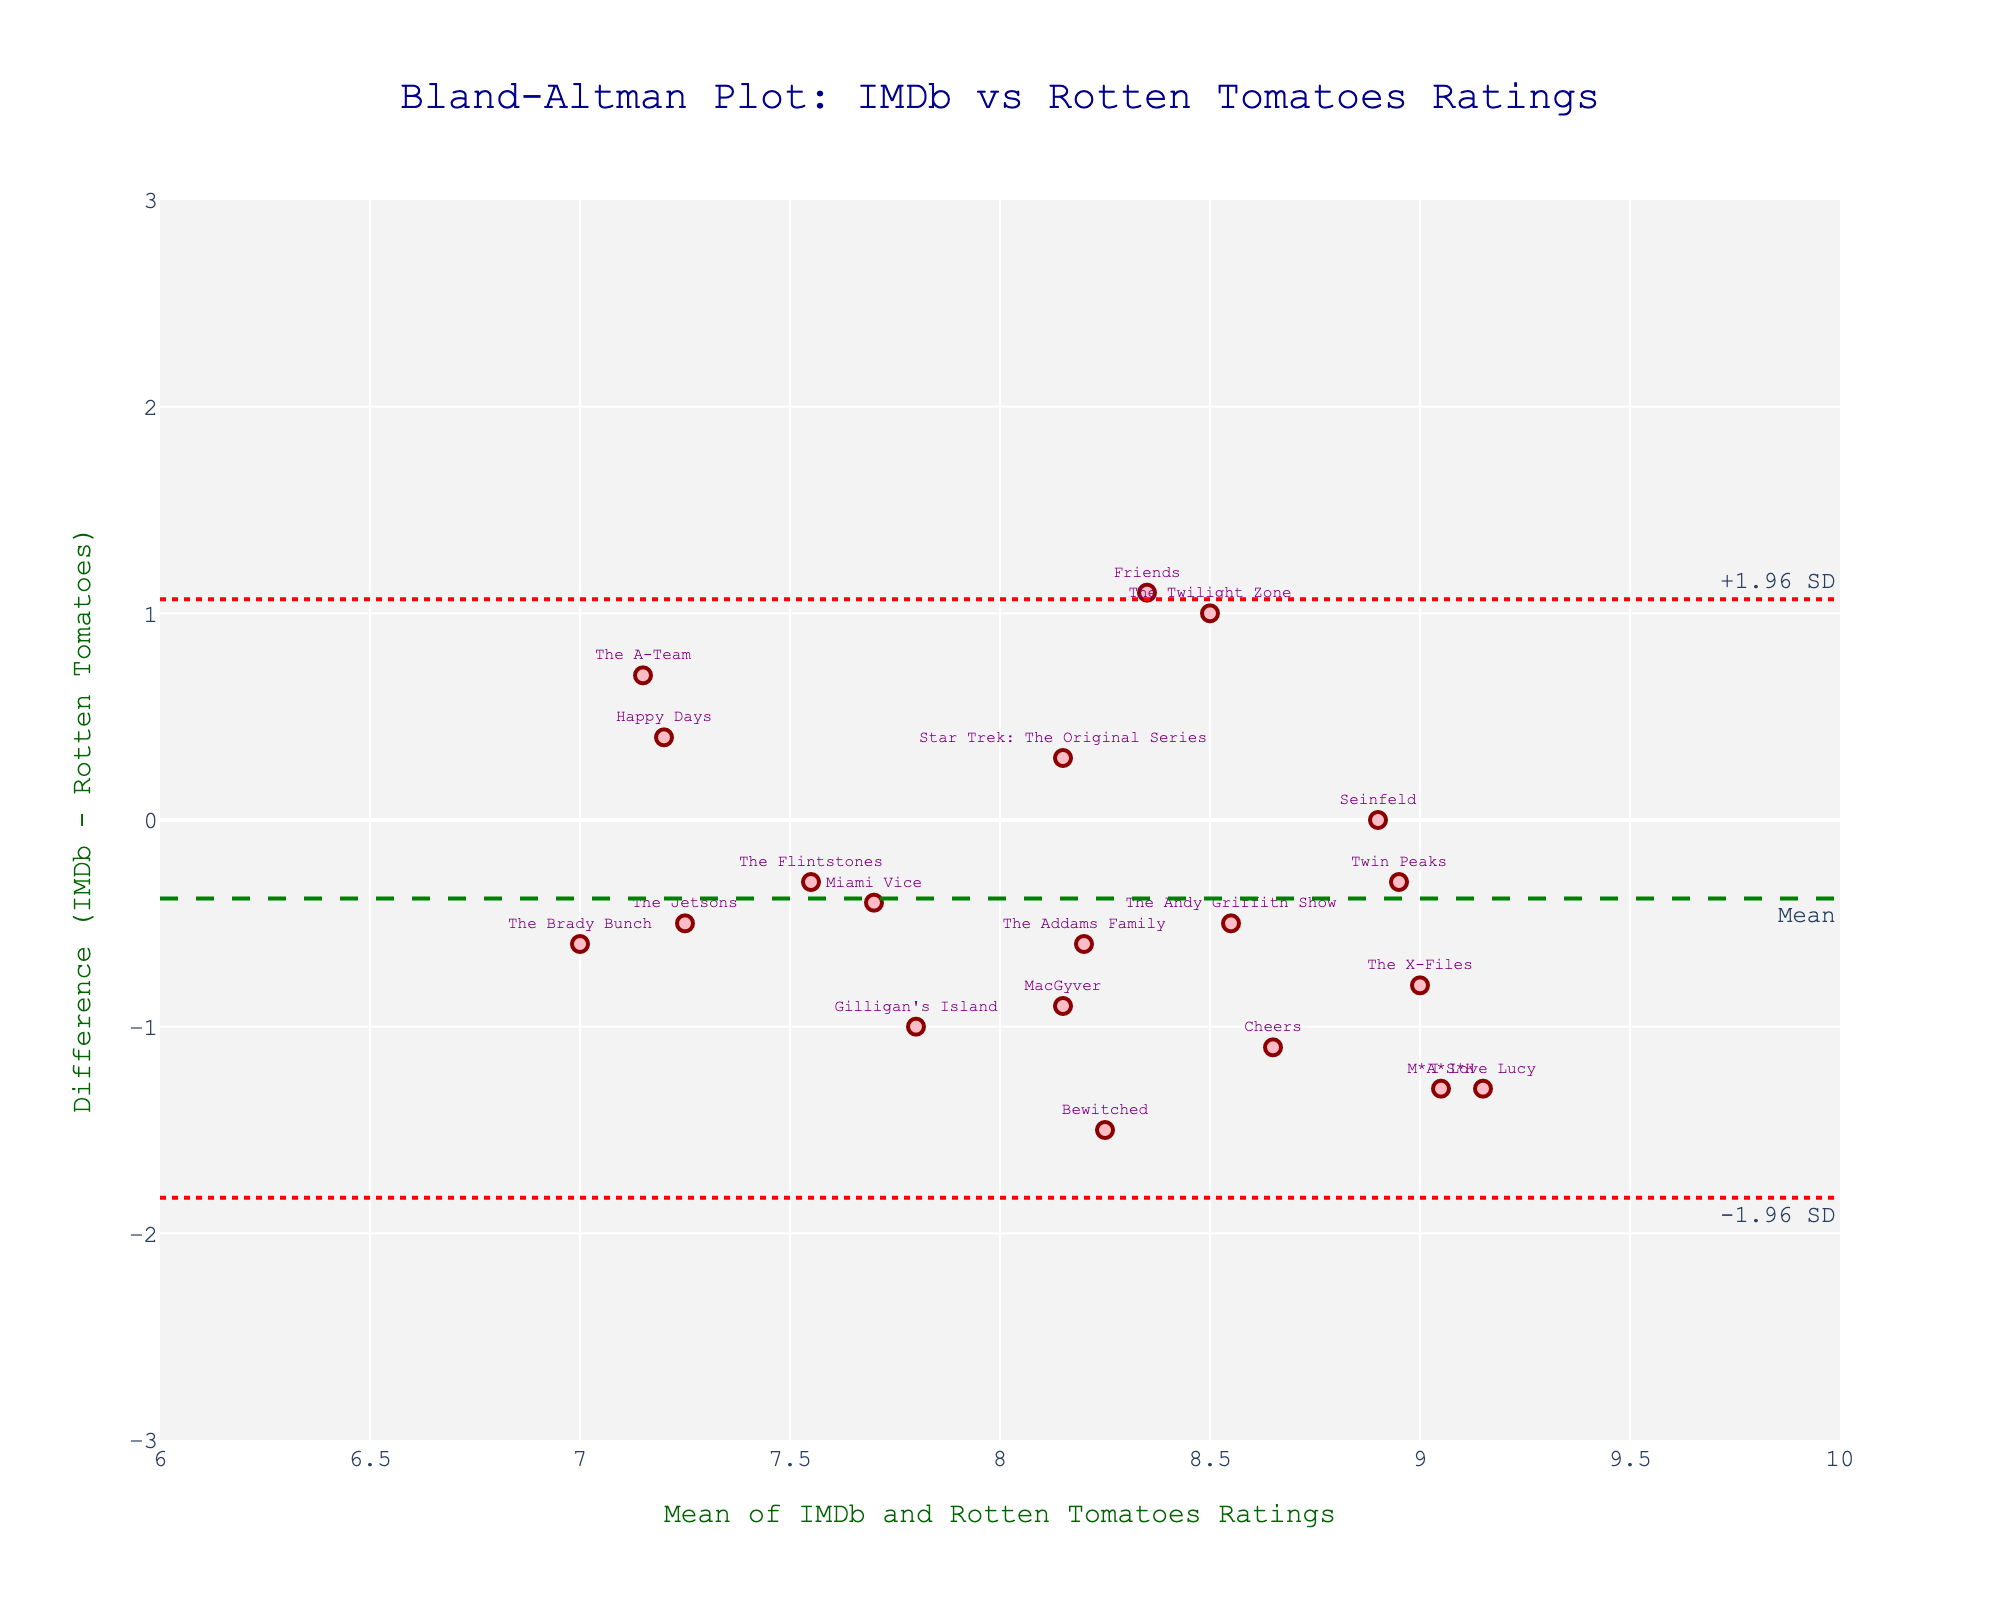What is the title of the figure? The title of the figure is located at the top. It states 'Bland-Altman Plot: IMDb vs Rotten Tomatoes Ratings', indicating the comparison being made between IMDb and Rotten Tomatoes ratings for vintage TV shows.
Answer: Bland-Altman Plot: IMDb vs Rotten Tomatoes Ratings What do the x-axis and y-axis represent? The x-axis represents the 'Mean of IMDb and Rotten Tomatoes Ratings', while the y-axis represents the 'Difference (IMDb - Rotten Tomatoes)'. This is based on the axis titles found on the figure.
Answer: Mean of IMDb and Rotten Tomatoes Ratings, Difference (IMDb - Rotten Tomatoes) How many TV shows are plotted in the figure? Each marker on the plot represents a TV show. By counting the markers, we can see there are 20 markers indicating 20 TV shows.
Answer: 20 Which TV show has the highest mean rating? By finding the marker with the highest x-axis value (mean rating), we can see that 'The Twilight Zone' has the highest mean rating among the plotted shows.
Answer: The Twilight Zone What are the colors of the markers, and what do they signify? The markers are pink with dark red outlines. The colors are used for visual distinction but do not signify any specific grouping or category in the data.
Answer: Pink with dark red outlines What is the mean difference in ratings? The mean difference can be found as a dashed green line labeled 'Mean'. This line represents the average difference between IMDb and Rotten Tomatoes ratings for the shows.
Answer: Mean difference line Between which two values is the limit of agreement? The limits of agreement are shown by the two dotted red lines and are labeled '-1.96 SD' and '+1.96 SD'. These lines indicate the range where most differences between the ratings fall.
Answer: -1.96 SD and +1.96 SD lines Which show has the greatest negative difference in ratings? By identifying the marker with the lowest y-axis value (difference in ratings), we can see that 'Friends' has the greatest negative difference in ratings.
Answer: Friends What is the range for the x-axis? The x-axis range is given by the lower and upper bounds of the axis, which span from 6 to 10 based on the axis labels.
Answer: 6 to 10 Which shows have a difference in ratings between -1 and 1? Shows with differences in ratings between -1 and 1 have markers that fall within this range on the y-axis. By examining the figure, shows like 'The Twilight Zone', 'Seinfeld', 'Star Trek: The Original Series', and 'Gilligan's Island' fit this criterion.
Answer: The Twilight Zone, Seinfeld, Star Trek: The Original Series, Gilligan's Island 